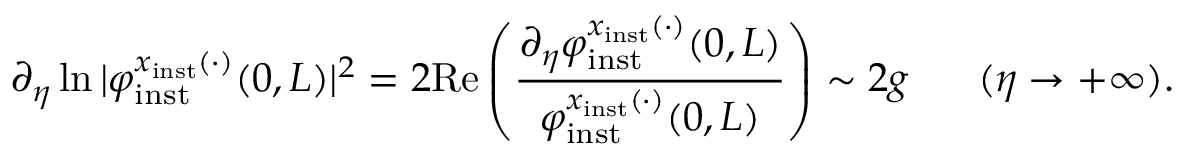<formula> <loc_0><loc_0><loc_500><loc_500>\partial _ { \eta } \ln | \varphi _ { i n s t } ^ { x _ { i n s t } ( \cdot ) } ( 0 , L ) | ^ { 2 } = 2 R e \left ( \frac { \partial _ { \eta } \varphi _ { i n s t } ^ { x _ { i n s t } ( \cdot ) } ( 0 , L ) } { \varphi _ { i n s t } ^ { x _ { i n s t } ( \cdot ) } ( 0 , L ) } \right ) \sim 2 g \quad \ ( \eta \to + \infty ) .</formula> 